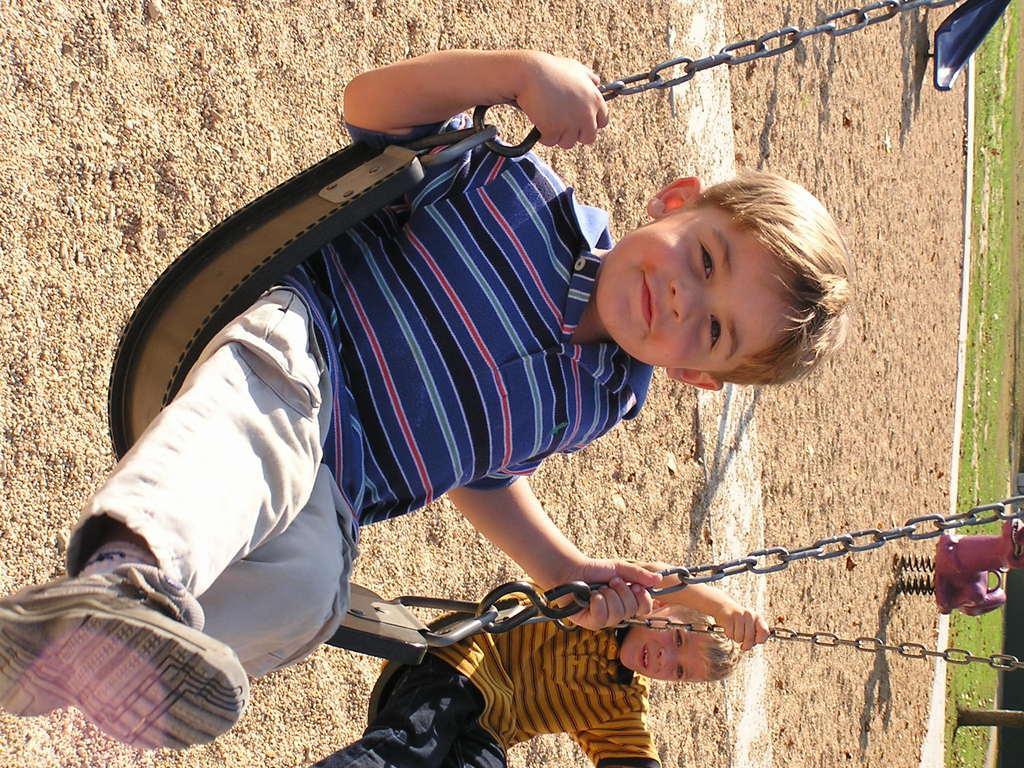Can you describe this image briefly? In the foreground of this picture, there are two boys swinging on a swing chair in the park. In the background, there is sand, slide and the grass. 